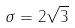<formula> <loc_0><loc_0><loc_500><loc_500>\sigma = 2 \sqrt { 3 }</formula> 